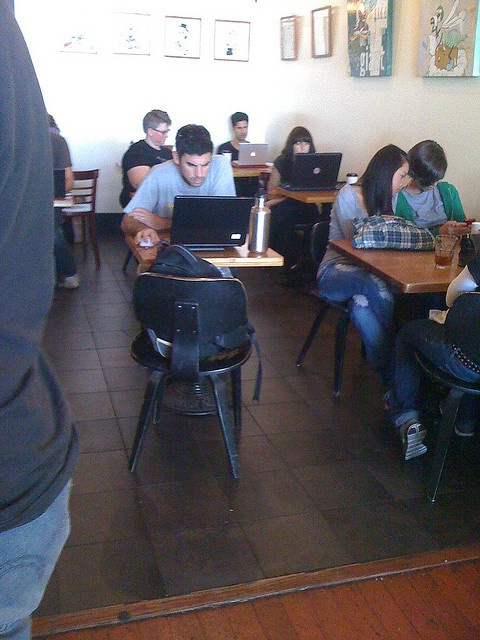Describe the objects in this image and their specific colors. I can see people in gray, blue, and navy tones, chair in gray, black, navy, and darkblue tones, people in gray, black, navy, and darkblue tones, people in gray, black, navy, and blue tones, and people in gray, lightblue, and darkgray tones in this image. 